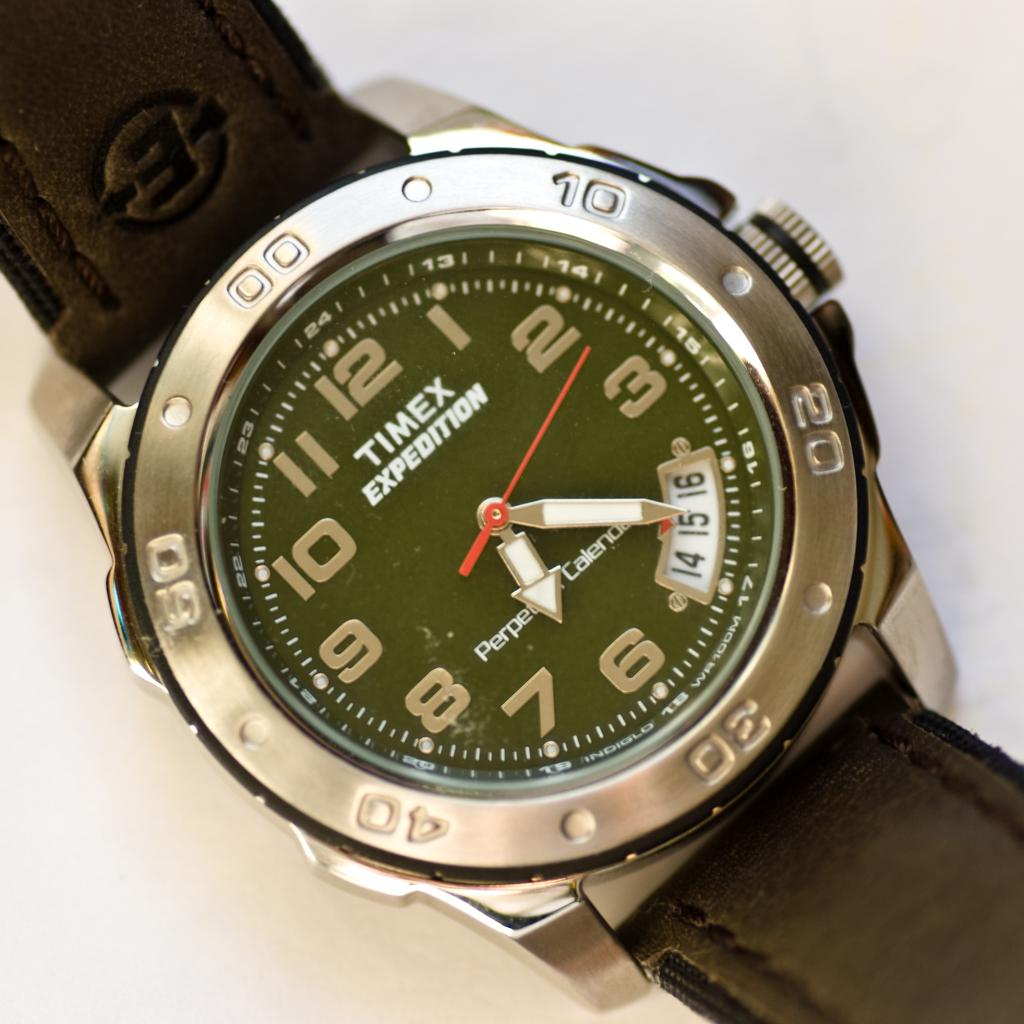<image>
Summarize the visual content of the image. A Timex watch that has a red hand on it 